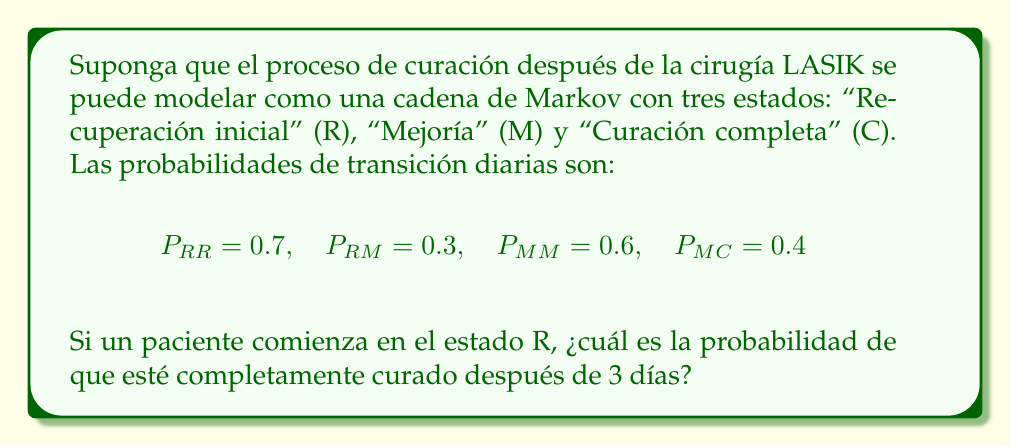Solve this math problem. Para resolver este problema, seguiremos estos pasos:

1) Primero, construimos la matriz de transición P:

   $$P = \begin{pmatrix}
   0.7 & 0.3 & 0 \\
   0 & 0.6 & 0.4 \\
   0 & 0 & 1
   \end{pmatrix}$$

2) Necesitamos calcular $P^3$, ya que queremos la probabilidad después de 3 días:

   $$P^3 = P \cdot P \cdot P$$

3) Realizando la multiplicación de matrices:

   $$P^2 = \begin{pmatrix}
   0.49 & 0.39 & 0.12 \\
   0 & 0.36 & 0.64 \\
   0 & 0 & 1
   \end{pmatrix}$$

   $$P^3 = \begin{pmatrix}
   0.343 & 0.3822 & 0.2748 \\
   0 & 0.216 & 0.784 \\
   0 & 0 & 1
   \end{pmatrix}$$

4) El paciente comienza en el estado R, por lo que nos interesa la primera fila de $P^3$.

5) La probabilidad de estar en el estado C (curación completa) después de 3 días es el elemento (1,3) de $P^3$, que es 0.2748.
Answer: 0.2748 